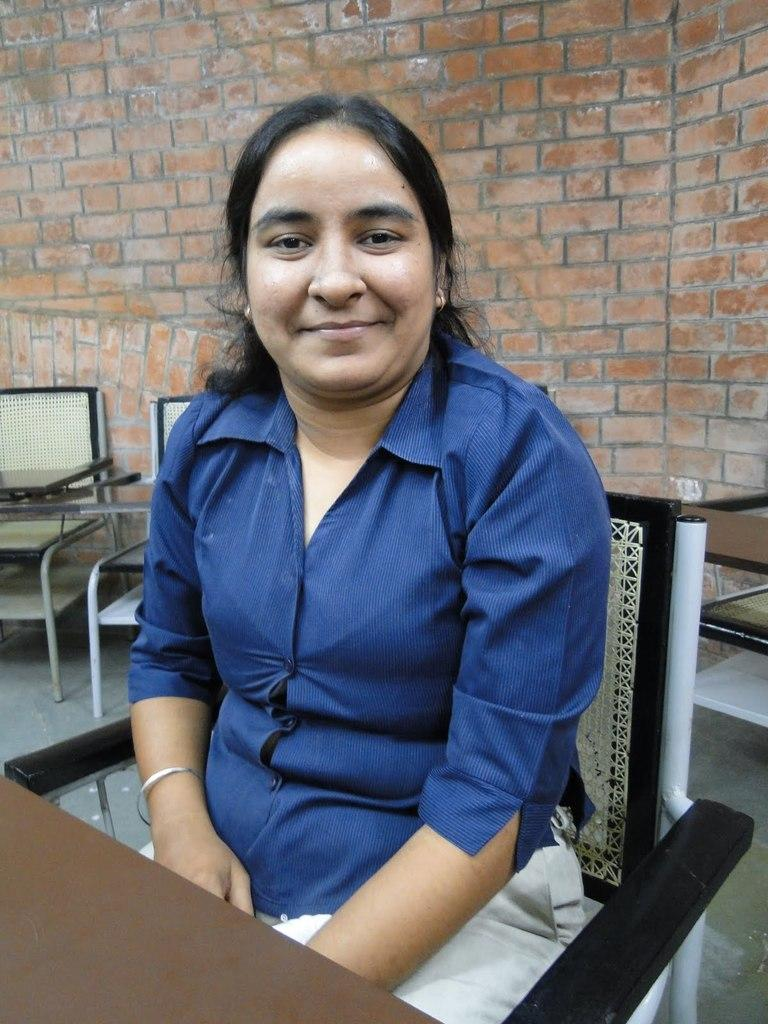What type of wall can be seen in the background of the image? There is a wall with bricks in the background. What furniture is present in the image? There are chairs and a table in the image. What is the woman in the image doing? The woman is sitting on one of the chairs and smiling. What type of hospital is visible in the background of the image? There is no hospital present in the image; it features a wall with bricks in the background. What color is the paint on the wall in the image? The provided facts do not mention the color of the paint on the wall, so we cannot determine that information from the image. 